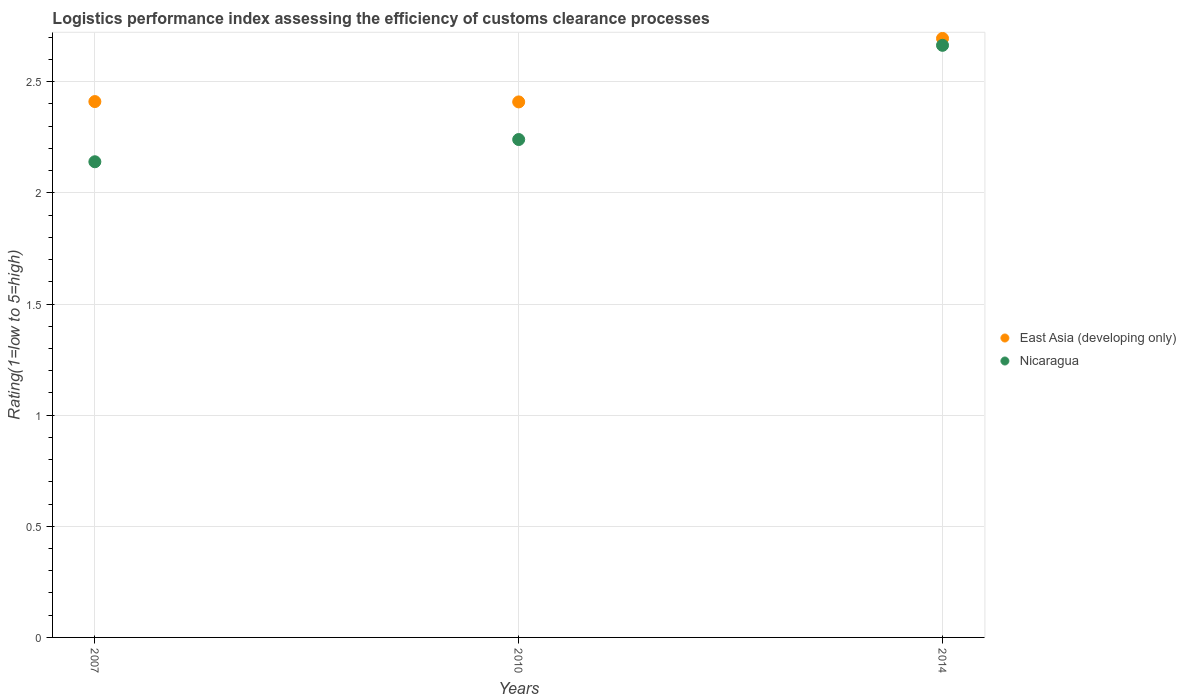How many different coloured dotlines are there?
Give a very brief answer. 2. What is the Logistic performance index in Nicaragua in 2007?
Ensure brevity in your answer.  2.14. Across all years, what is the maximum Logistic performance index in East Asia (developing only)?
Your response must be concise. 2.69. Across all years, what is the minimum Logistic performance index in Nicaragua?
Ensure brevity in your answer.  2.14. In which year was the Logistic performance index in Nicaragua minimum?
Offer a terse response. 2007. What is the total Logistic performance index in Nicaragua in the graph?
Keep it short and to the point. 7.04. What is the difference between the Logistic performance index in East Asia (developing only) in 2007 and that in 2010?
Offer a terse response. 0. What is the difference between the Logistic performance index in East Asia (developing only) in 2007 and the Logistic performance index in Nicaragua in 2010?
Provide a short and direct response. 0.17. What is the average Logistic performance index in Nicaragua per year?
Keep it short and to the point. 2.35. In the year 2014, what is the difference between the Logistic performance index in Nicaragua and Logistic performance index in East Asia (developing only)?
Offer a very short reply. -0.03. In how many years, is the Logistic performance index in East Asia (developing only) greater than 2.1?
Provide a succinct answer. 3. What is the ratio of the Logistic performance index in East Asia (developing only) in 2007 to that in 2014?
Provide a succinct answer. 0.89. What is the difference between the highest and the second highest Logistic performance index in Nicaragua?
Your response must be concise. 0.42. What is the difference between the highest and the lowest Logistic performance index in Nicaragua?
Ensure brevity in your answer.  0.52. Is the sum of the Logistic performance index in East Asia (developing only) in 2007 and 2014 greater than the maximum Logistic performance index in Nicaragua across all years?
Provide a succinct answer. Yes. Does the Logistic performance index in East Asia (developing only) monotonically increase over the years?
Give a very brief answer. No. Is the Logistic performance index in Nicaragua strictly less than the Logistic performance index in East Asia (developing only) over the years?
Provide a succinct answer. Yes. How many dotlines are there?
Your answer should be compact. 2. How many years are there in the graph?
Your answer should be compact. 3. What is the difference between two consecutive major ticks on the Y-axis?
Offer a very short reply. 0.5. Where does the legend appear in the graph?
Keep it short and to the point. Center right. How are the legend labels stacked?
Your answer should be very brief. Vertical. What is the title of the graph?
Offer a terse response. Logistics performance index assessing the efficiency of customs clearance processes. Does "Israel" appear as one of the legend labels in the graph?
Provide a succinct answer. No. What is the label or title of the Y-axis?
Ensure brevity in your answer.  Rating(1=low to 5=high). What is the Rating(1=low to 5=high) of East Asia (developing only) in 2007?
Give a very brief answer. 2.41. What is the Rating(1=low to 5=high) of Nicaragua in 2007?
Offer a terse response. 2.14. What is the Rating(1=low to 5=high) of East Asia (developing only) in 2010?
Your response must be concise. 2.41. What is the Rating(1=low to 5=high) of Nicaragua in 2010?
Keep it short and to the point. 2.24. What is the Rating(1=low to 5=high) of East Asia (developing only) in 2014?
Your answer should be very brief. 2.69. What is the Rating(1=low to 5=high) in Nicaragua in 2014?
Keep it short and to the point. 2.66. Across all years, what is the maximum Rating(1=low to 5=high) in East Asia (developing only)?
Your response must be concise. 2.69. Across all years, what is the maximum Rating(1=low to 5=high) of Nicaragua?
Provide a succinct answer. 2.66. Across all years, what is the minimum Rating(1=low to 5=high) in East Asia (developing only)?
Provide a short and direct response. 2.41. Across all years, what is the minimum Rating(1=low to 5=high) in Nicaragua?
Provide a short and direct response. 2.14. What is the total Rating(1=low to 5=high) in East Asia (developing only) in the graph?
Your answer should be very brief. 7.51. What is the total Rating(1=low to 5=high) in Nicaragua in the graph?
Keep it short and to the point. 7.04. What is the difference between the Rating(1=low to 5=high) in East Asia (developing only) in 2007 and that in 2010?
Your response must be concise. 0. What is the difference between the Rating(1=low to 5=high) in Nicaragua in 2007 and that in 2010?
Provide a short and direct response. -0.1. What is the difference between the Rating(1=low to 5=high) of East Asia (developing only) in 2007 and that in 2014?
Your answer should be very brief. -0.28. What is the difference between the Rating(1=low to 5=high) in Nicaragua in 2007 and that in 2014?
Make the answer very short. -0.52. What is the difference between the Rating(1=low to 5=high) in East Asia (developing only) in 2010 and that in 2014?
Offer a terse response. -0.29. What is the difference between the Rating(1=low to 5=high) of Nicaragua in 2010 and that in 2014?
Offer a very short reply. -0.42. What is the difference between the Rating(1=low to 5=high) in East Asia (developing only) in 2007 and the Rating(1=low to 5=high) in Nicaragua in 2010?
Offer a very short reply. 0.17. What is the difference between the Rating(1=low to 5=high) in East Asia (developing only) in 2007 and the Rating(1=low to 5=high) in Nicaragua in 2014?
Offer a very short reply. -0.25. What is the difference between the Rating(1=low to 5=high) of East Asia (developing only) in 2010 and the Rating(1=low to 5=high) of Nicaragua in 2014?
Give a very brief answer. -0.25. What is the average Rating(1=low to 5=high) of East Asia (developing only) per year?
Your answer should be compact. 2.5. What is the average Rating(1=low to 5=high) of Nicaragua per year?
Your answer should be compact. 2.35. In the year 2007, what is the difference between the Rating(1=low to 5=high) of East Asia (developing only) and Rating(1=low to 5=high) of Nicaragua?
Make the answer very short. 0.27. In the year 2010, what is the difference between the Rating(1=low to 5=high) in East Asia (developing only) and Rating(1=low to 5=high) in Nicaragua?
Offer a very short reply. 0.17. In the year 2014, what is the difference between the Rating(1=low to 5=high) of East Asia (developing only) and Rating(1=low to 5=high) of Nicaragua?
Offer a very short reply. 0.03. What is the ratio of the Rating(1=low to 5=high) of Nicaragua in 2007 to that in 2010?
Your answer should be compact. 0.96. What is the ratio of the Rating(1=low to 5=high) of East Asia (developing only) in 2007 to that in 2014?
Give a very brief answer. 0.89. What is the ratio of the Rating(1=low to 5=high) in Nicaragua in 2007 to that in 2014?
Your answer should be very brief. 0.8. What is the ratio of the Rating(1=low to 5=high) in East Asia (developing only) in 2010 to that in 2014?
Your answer should be very brief. 0.89. What is the ratio of the Rating(1=low to 5=high) in Nicaragua in 2010 to that in 2014?
Offer a very short reply. 0.84. What is the difference between the highest and the second highest Rating(1=low to 5=high) in East Asia (developing only)?
Your answer should be compact. 0.28. What is the difference between the highest and the second highest Rating(1=low to 5=high) of Nicaragua?
Provide a short and direct response. 0.42. What is the difference between the highest and the lowest Rating(1=low to 5=high) of East Asia (developing only)?
Provide a short and direct response. 0.29. What is the difference between the highest and the lowest Rating(1=low to 5=high) of Nicaragua?
Your response must be concise. 0.52. 